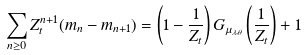Convert formula to latex. <formula><loc_0><loc_0><loc_500><loc_500>\sum _ { n \geq 0 } Z _ { t } ^ { n + 1 } ( m _ { n } - m _ { n + 1 } ) = \left ( 1 - \frac { 1 } { Z _ { t } } \right ) G _ { \mu _ { \lambda , \theta } } \left ( \frac { 1 } { Z _ { t } } \right ) + 1</formula> 